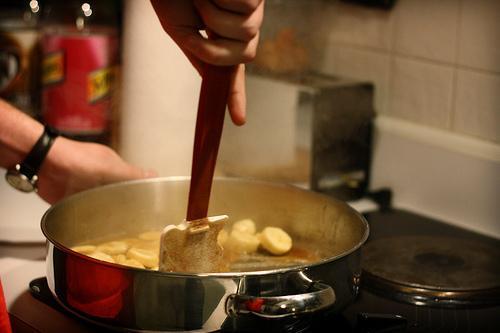How many pots are on the stove?
Give a very brief answer. 1. How many soda bottles are there?
Give a very brief answer. 2. 